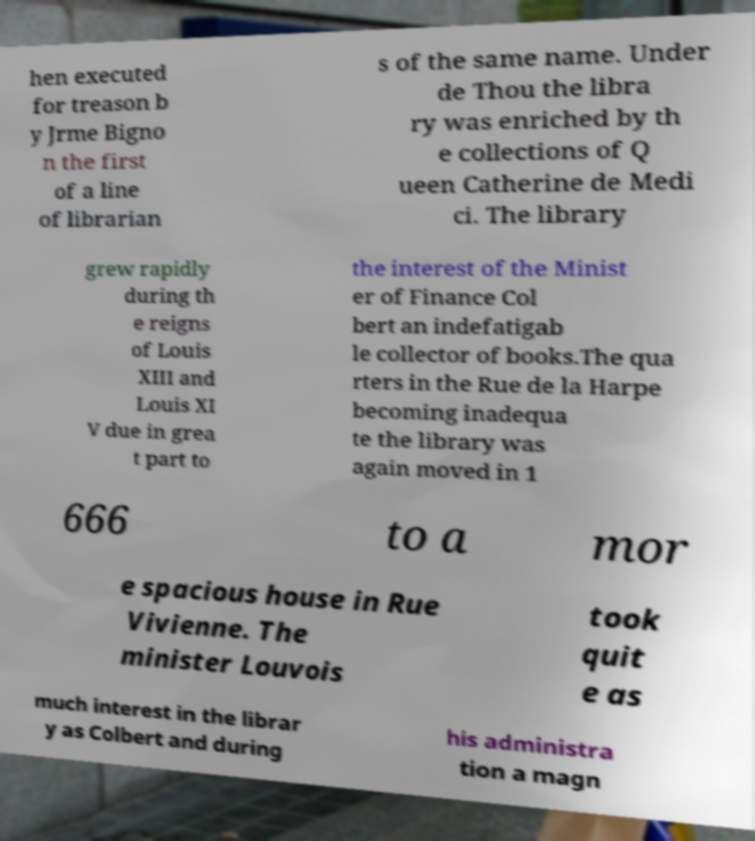Can you read and provide the text displayed in the image?This photo seems to have some interesting text. Can you extract and type it out for me? hen executed for treason b y Jrme Bigno n the first of a line of librarian s of the same name. Under de Thou the libra ry was enriched by th e collections of Q ueen Catherine de Medi ci. The library grew rapidly during th e reigns of Louis XIII and Louis XI V due in grea t part to the interest of the Minist er of Finance Col bert an indefatigab le collector of books.The qua rters in the Rue de la Harpe becoming inadequa te the library was again moved in 1 666 to a mor e spacious house in Rue Vivienne. The minister Louvois took quit e as much interest in the librar y as Colbert and during his administra tion a magn 